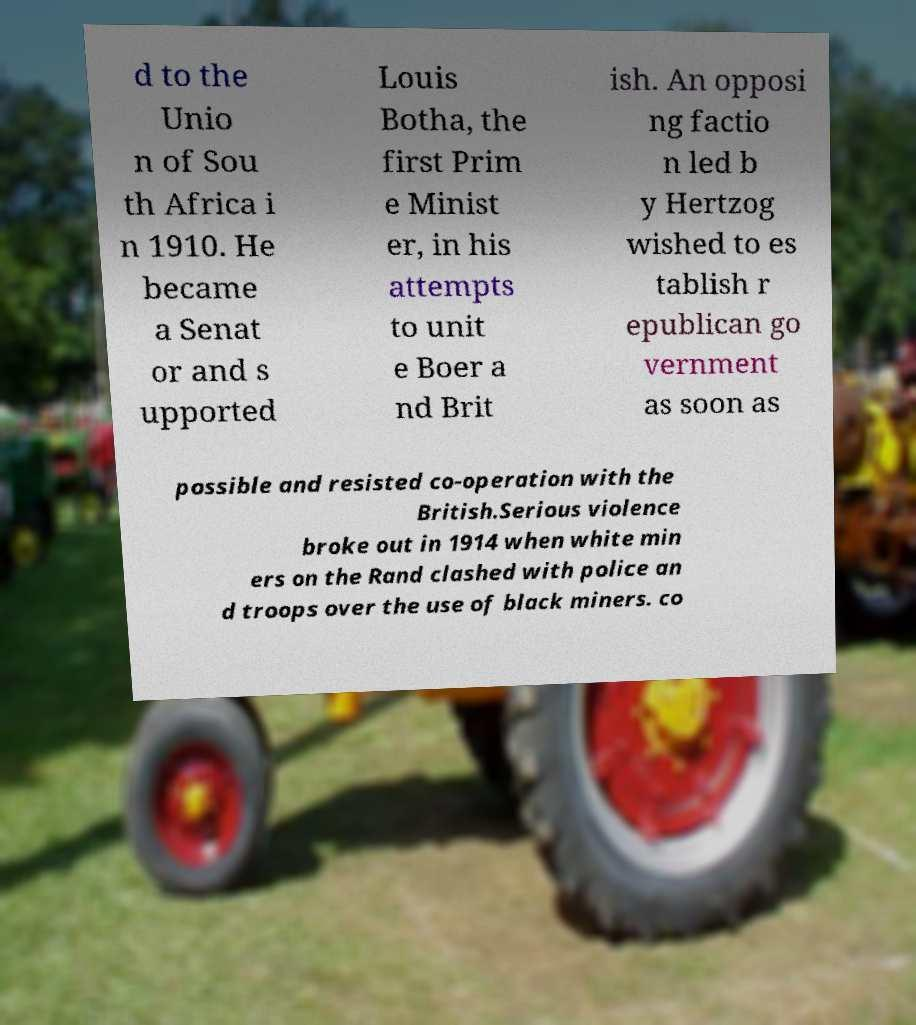Can you accurately transcribe the text from the provided image for me? d to the Unio n of Sou th Africa i n 1910. He became a Senat or and s upported Louis Botha, the first Prim e Minist er, in his attempts to unit e Boer a nd Brit ish. An opposi ng factio n led b y Hertzog wished to es tablish r epublican go vernment as soon as possible and resisted co-operation with the British.Serious violence broke out in 1914 when white min ers on the Rand clashed with police an d troops over the use of black miners. co 